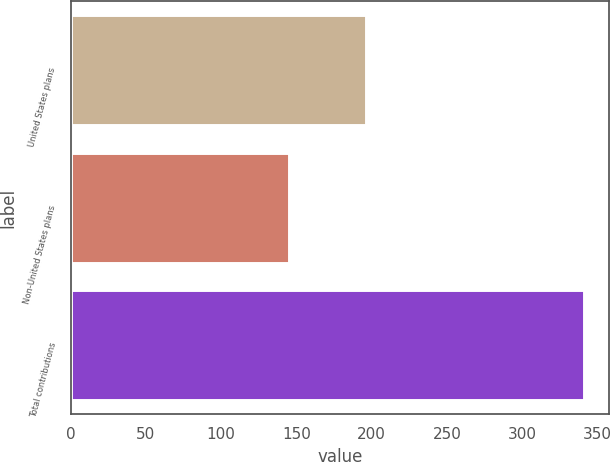<chart> <loc_0><loc_0><loc_500><loc_500><bar_chart><fcel>United States plans<fcel>Non-United States plans<fcel>Total contributions<nl><fcel>196<fcel>145<fcel>341<nl></chart> 